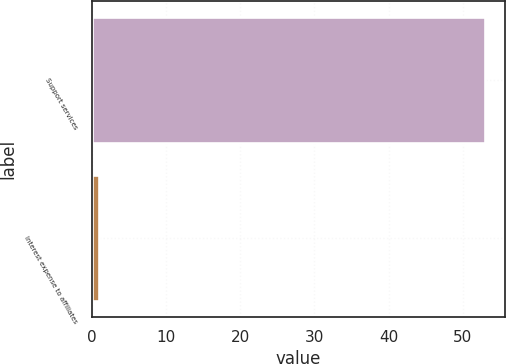Convert chart to OTSL. <chart><loc_0><loc_0><loc_500><loc_500><bar_chart><fcel>Support services<fcel>Interest expense to affiliates<nl><fcel>53<fcel>1<nl></chart> 